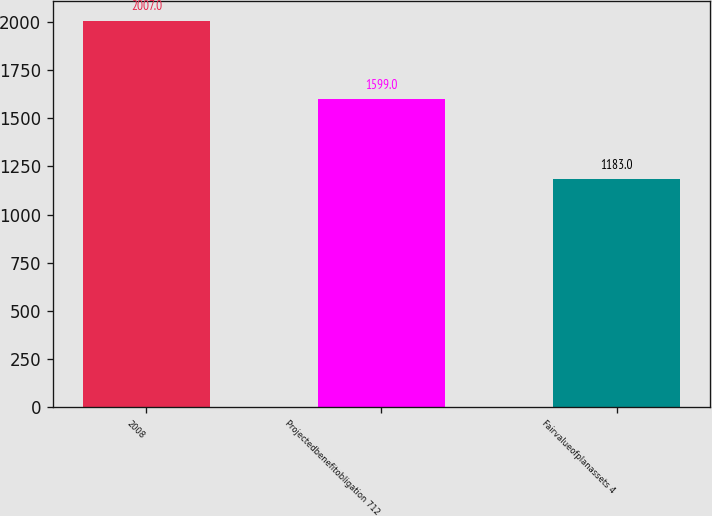Convert chart. <chart><loc_0><loc_0><loc_500><loc_500><bar_chart><fcel>2008<fcel>Projectedbenefitobligation 712<fcel>Fairvalueofplanassets 4<nl><fcel>2007<fcel>1599<fcel>1183<nl></chart> 